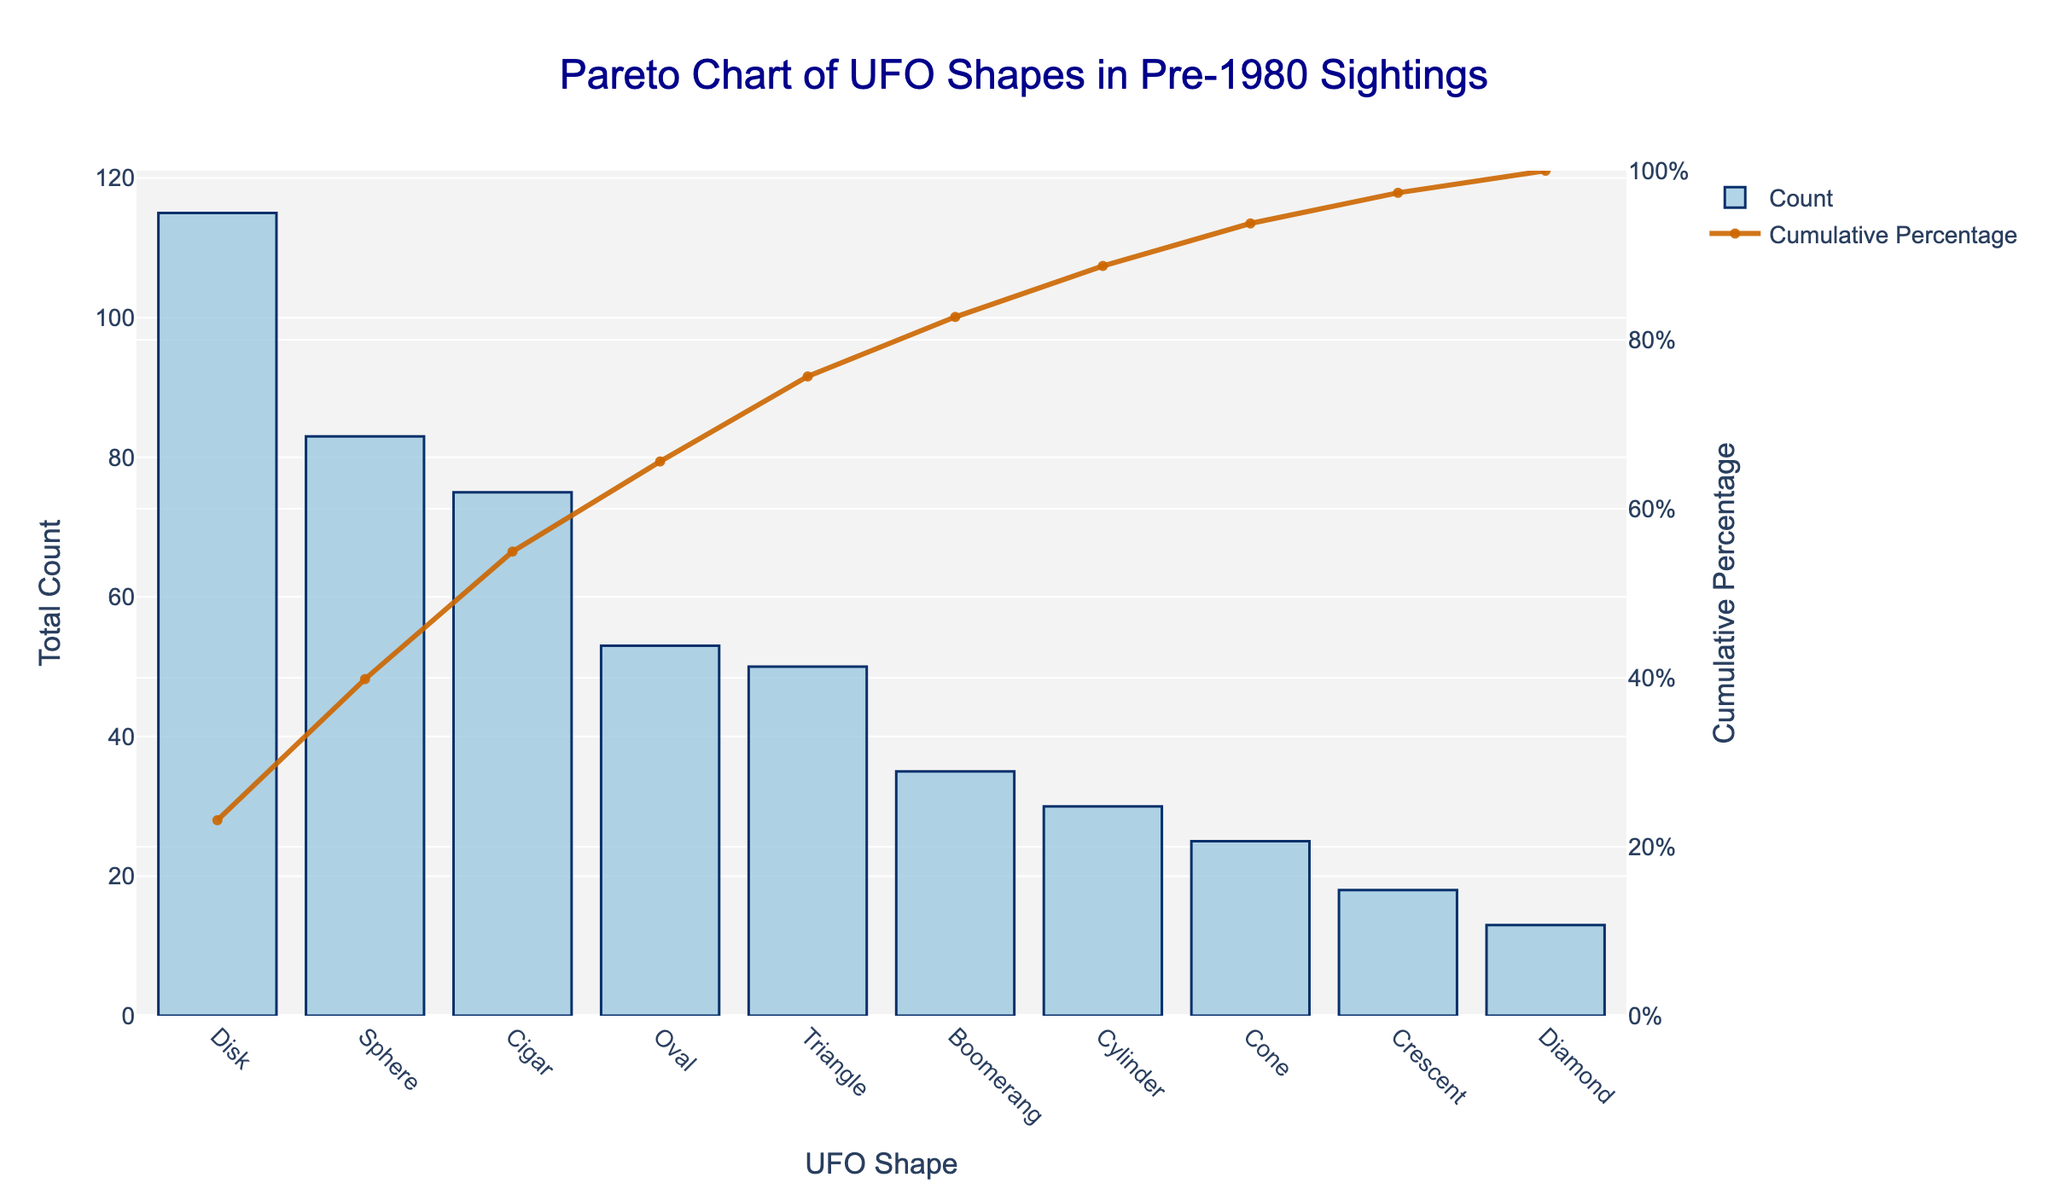What is the title of the chart? The title is located at the top of the chart in a larger font size and different color. By looking at this, we can see the name of the chart.
Answer: Pareto Chart of UFO Shapes in Pre-1980 Sightings Which UFO shape has the highest total count? The highest bar in the bar chart represents the UFO shape with the highest total count.
Answer: Disk What is the total count for the Sphere shape? Locate the bar representing the Sphere shape in the chart. The height of the bar provides the total count.
Answer: 83 How many shapes have a total count above 20? Look at the bars and identify those with heights above the 20 mark on the y-axis. Count these bars.
Answer: 4 Which UFO shape ranks second in terms of total count? Find the second tallest bar in the chart, which represents the UFO shape with the second highest total count.
Answer: Cigar What is the cumulative percentage of the top two UFO shapes? Examine the line chart that indicates the cumulative percentage. Find the cumulative percentage value aligning with the second shape (Cigar).
Answer: 51.6% How does the total count of the Diamond shape compare to the Crescent shape? Compare the heights of the bars representing the Diamond and Crescent shapes.
Answer: Crescent has a higher total count than Diamond How many UFO shapes account for at least 80% of the total sightings? Follow the cumulative percentage line until it reaches or exceeds 80%, and count the number of shapes up to that point.
Answer: 7 What is the total count difference between the Disk and the Triangle shapes? Note the totals of the Disk and Triangle shapes from their respective bars, then subtract the Triangle's total from the Disk's total.
Answer: 19 Which UFO shape has a cumulative percentage closest to 50%? Find the shape where the cumulative percentage line crosses or is nearest to 50%.
Answer: Sphere 